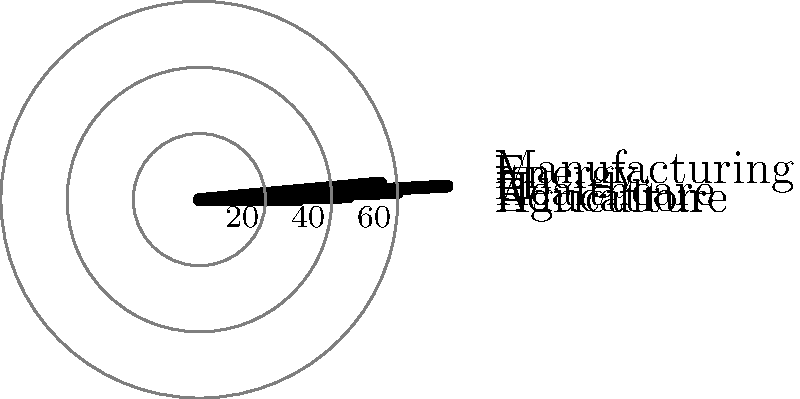The polar bar chart above illustrates the distribution of innovation grants (in millions of Ngultrum) across various sectors in Bhutan. Which sector received the highest amount of funding, and what is the total amount of grants distributed across all sectors? To solve this problem, we need to follow these steps:

1. Identify the sector with the highest bar in the polar chart:
   By examining the chart, we can see that the longest bar corresponds to the "Healthcare" sector.

2. Determine the value for the Healthcare sector:
   The Healthcare bar extends to the 75 million Ngultrum mark.

3. Sum up the values for all sectors:
   Agriculture: 30 million
   Education: 45 million
   Healthcare: 75 million
   IT: 40 million
   Energy: 55 million
   Manufacturing: 60 million

   Total = 30 + 45 + 75 + 40 + 55 + 60 = 305 million Ngultrum

Therefore, Healthcare received the highest amount of funding at 75 million Ngultrum, and the total amount of grants distributed across all sectors is 305 million Ngultrum.
Answer: Healthcare, 305 million Ngultrum 